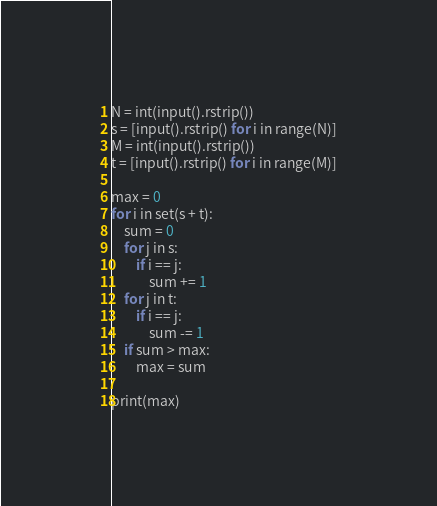Convert code to text. <code><loc_0><loc_0><loc_500><loc_500><_Python_>N = int(input().rstrip())
s = [input().rstrip() for i in range(N)]
M = int(input().rstrip())
t = [input().rstrip() for i in range(M)]

max = 0
for i in set(s + t):
    sum = 0
    for j in s:
        if i == j:
            sum += 1
    for j in t:
        if i == j:
            sum -= 1
    if sum > max:
        max = sum

print(max)</code> 